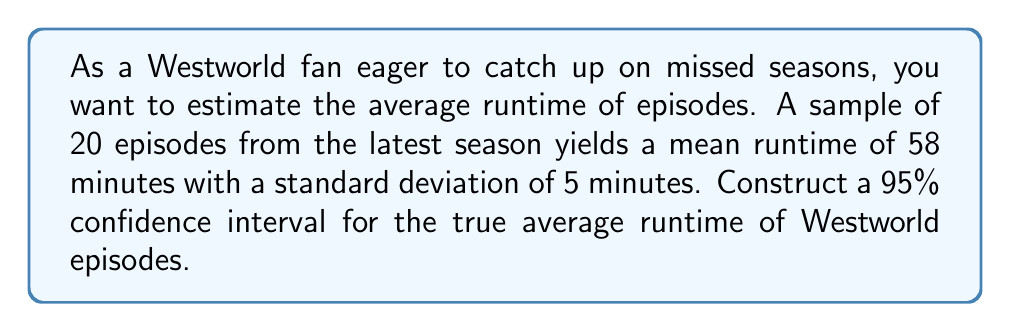Give your solution to this math problem. To construct a 95% confidence interval for the true average runtime of Westworld episodes, we'll follow these steps:

1. Identify the given information:
   - Sample size: $n = 20$
   - Sample mean: $\bar{x} = 58$ minutes
   - Sample standard deviation: $s = 5$ minutes
   - Confidence level: 95% (α = 0.05)

2. Determine the critical value:
   For a 95% confidence interval with 19 degrees of freedom (n-1), we use the t-distribution. The critical value is $t_{0.025, 19} = 2.093$ (from t-table or calculator).

3. Calculate the margin of error:
   Margin of error = $t_{0.025, 19} \cdot \frac{s}{\sqrt{n}}$
   $= 2.093 \cdot \frac{5}{\sqrt{20}}$
   $= 2.093 \cdot 1.118$
   $= 2.340$

4. Construct the confidence interval:
   CI = $(\bar{x} - \text{margin of error}, \bar{x} + \text{margin of error})$
   $= (58 - 2.340, 58 + 2.340)$
   $= (55.66, 60.34)$

Therefore, we can be 95% confident that the true average runtime of Westworld episodes falls between 55.66 and 60.34 minutes.
Answer: (55.66, 60.34) minutes 